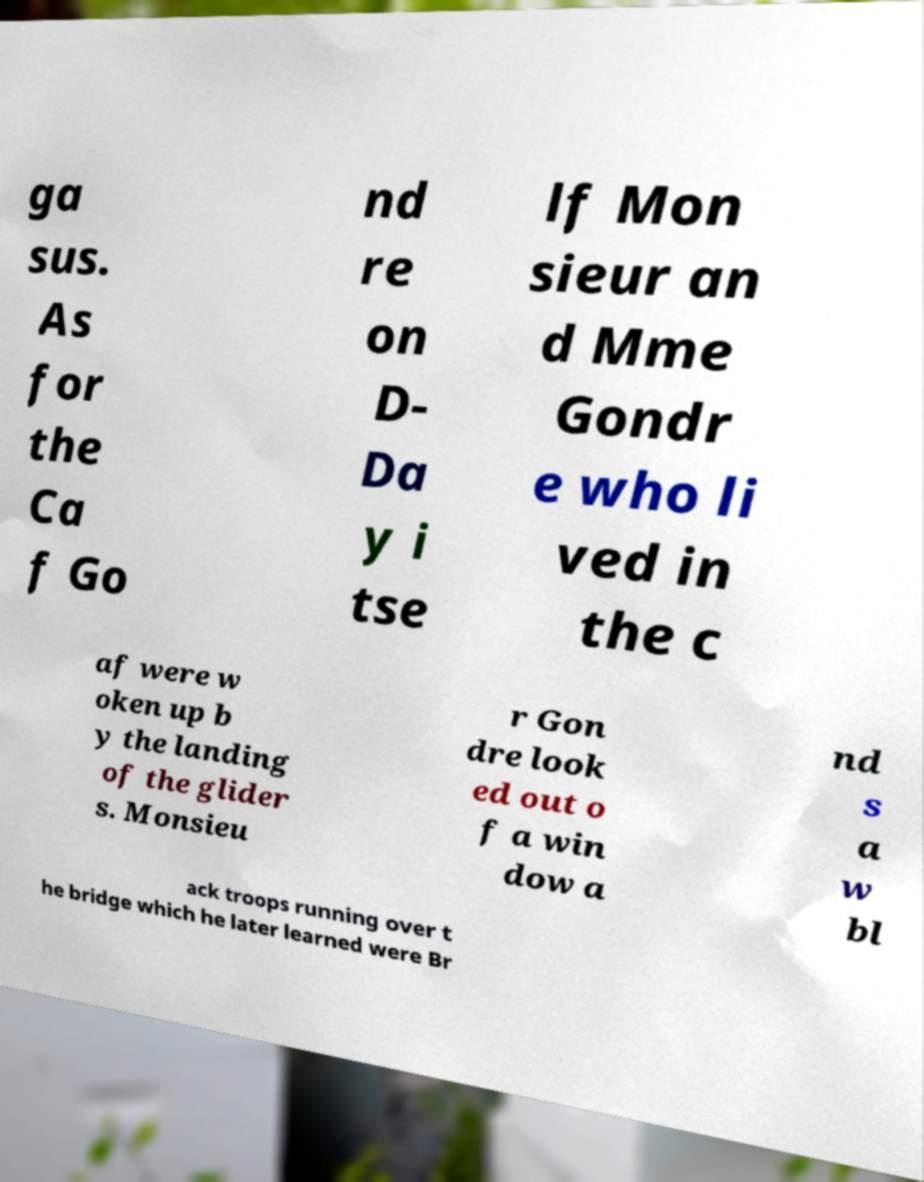Could you extract and type out the text from this image? ga sus. As for the Ca f Go nd re on D- Da y i tse lf Mon sieur an d Mme Gondr e who li ved in the c af were w oken up b y the landing of the glider s. Monsieu r Gon dre look ed out o f a win dow a nd s a w bl ack troops running over t he bridge which he later learned were Br 